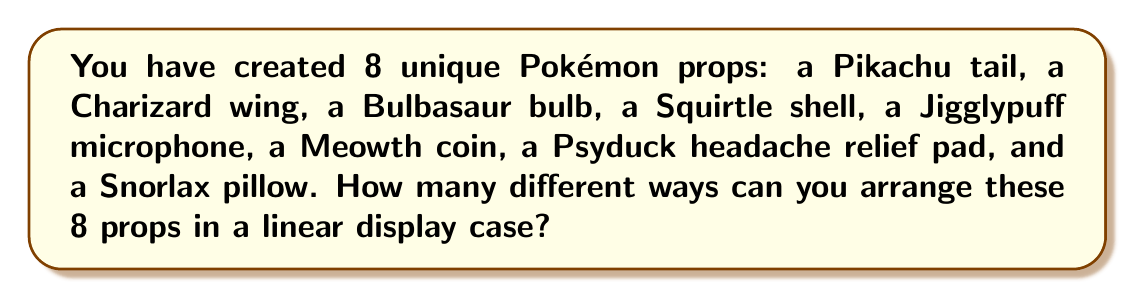Solve this math problem. To solve this problem, we need to consider the following:

1. We have 8 distinct Pokémon props.
2. We want to arrange all of them in a linear display case.
3. The order matters (e.g., Pikachu tail first is different from Pikachu tail last).

This scenario is a perfect example of a permutation problem. When we have n distinct objects and we want to arrange all of them, the number of ways to do so is given by the factorial of n, denoted as n!.

In this case:
n = 8 (number of props)

The formula for the number of permutations is:

$$ P(8) = 8! $$

To calculate 8!, we multiply all integers from 1 to 8:

$$ 8! = 8 \times 7 \times 6 \times 5 \times 4 \times 3 \times 2 \times 1 = 40,320 $$

Therefore, there are 40,320 different ways to arrange the 8 Pokémon props in the linear display case.
Answer: 40,320 